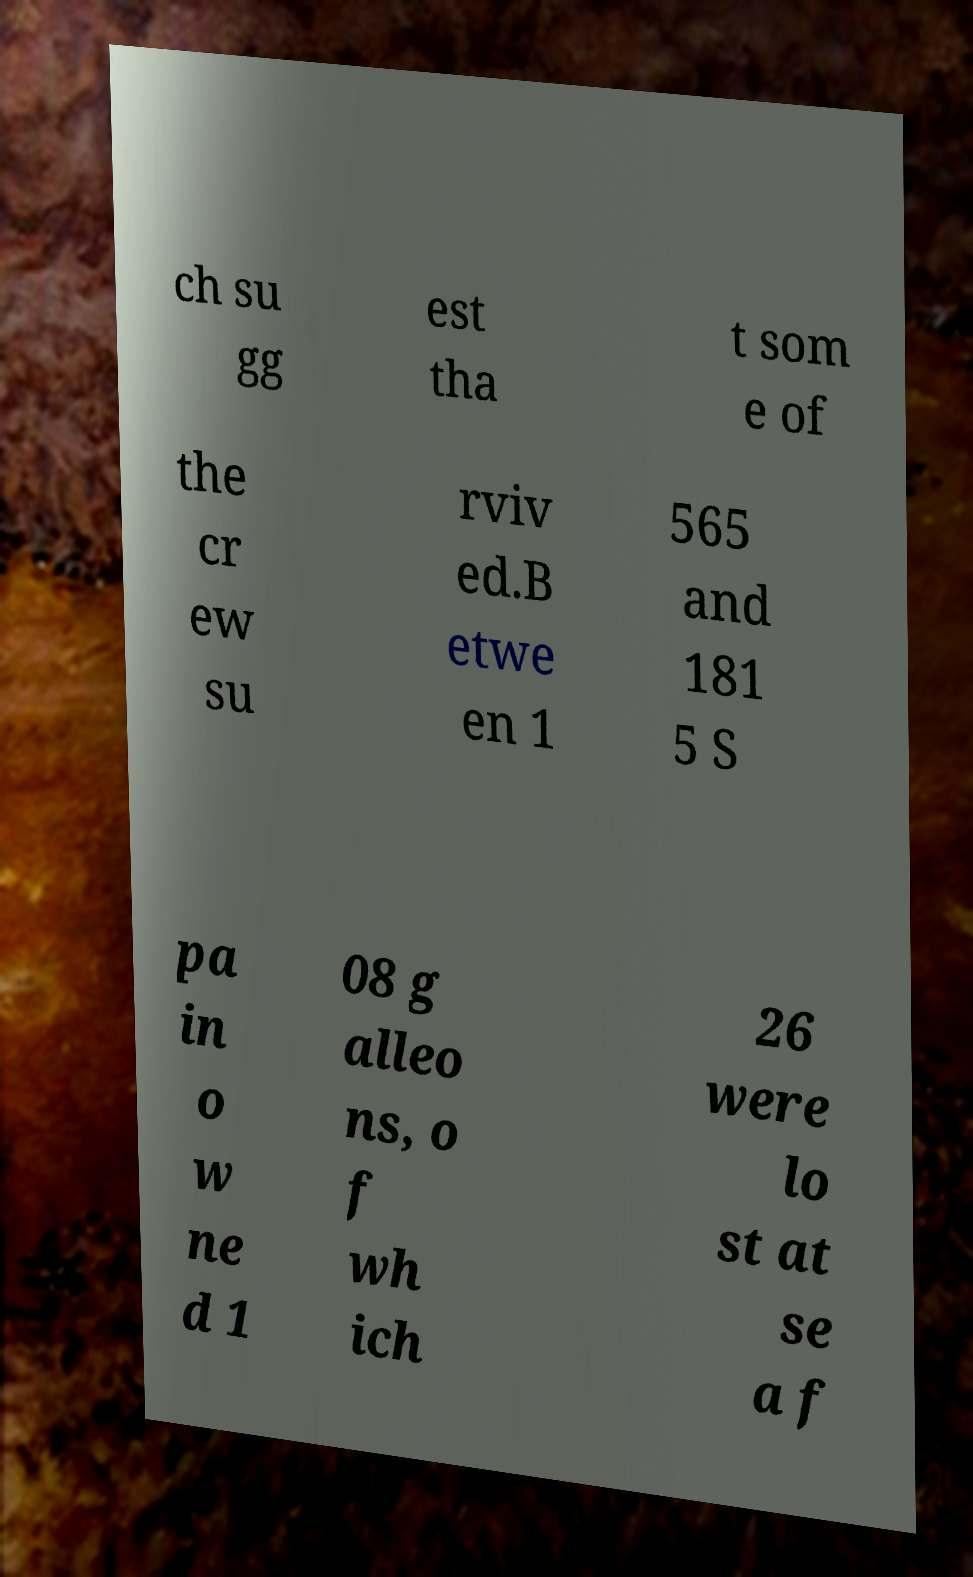For documentation purposes, I need the text within this image transcribed. Could you provide that? ch su gg est tha t som e of the cr ew su rviv ed.B etwe en 1 565 and 181 5 S pa in o w ne d 1 08 g alleo ns, o f wh ich 26 were lo st at se a f 